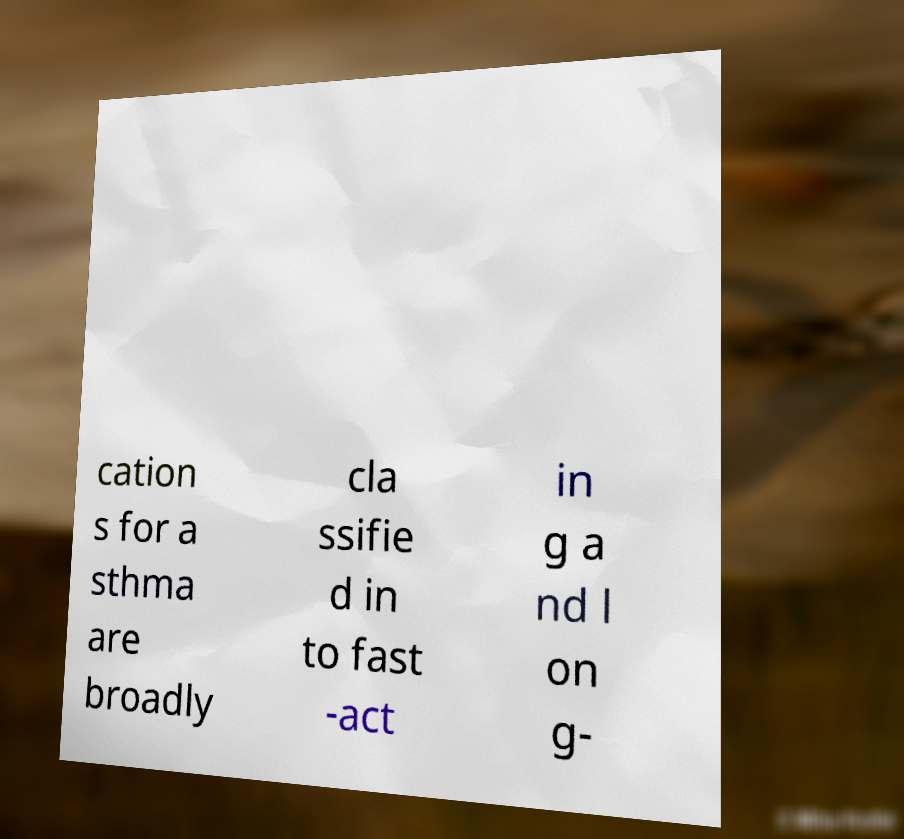Please read and relay the text visible in this image. What does it say? cation s for a sthma are broadly cla ssifie d in to fast -act in g a nd l on g- 